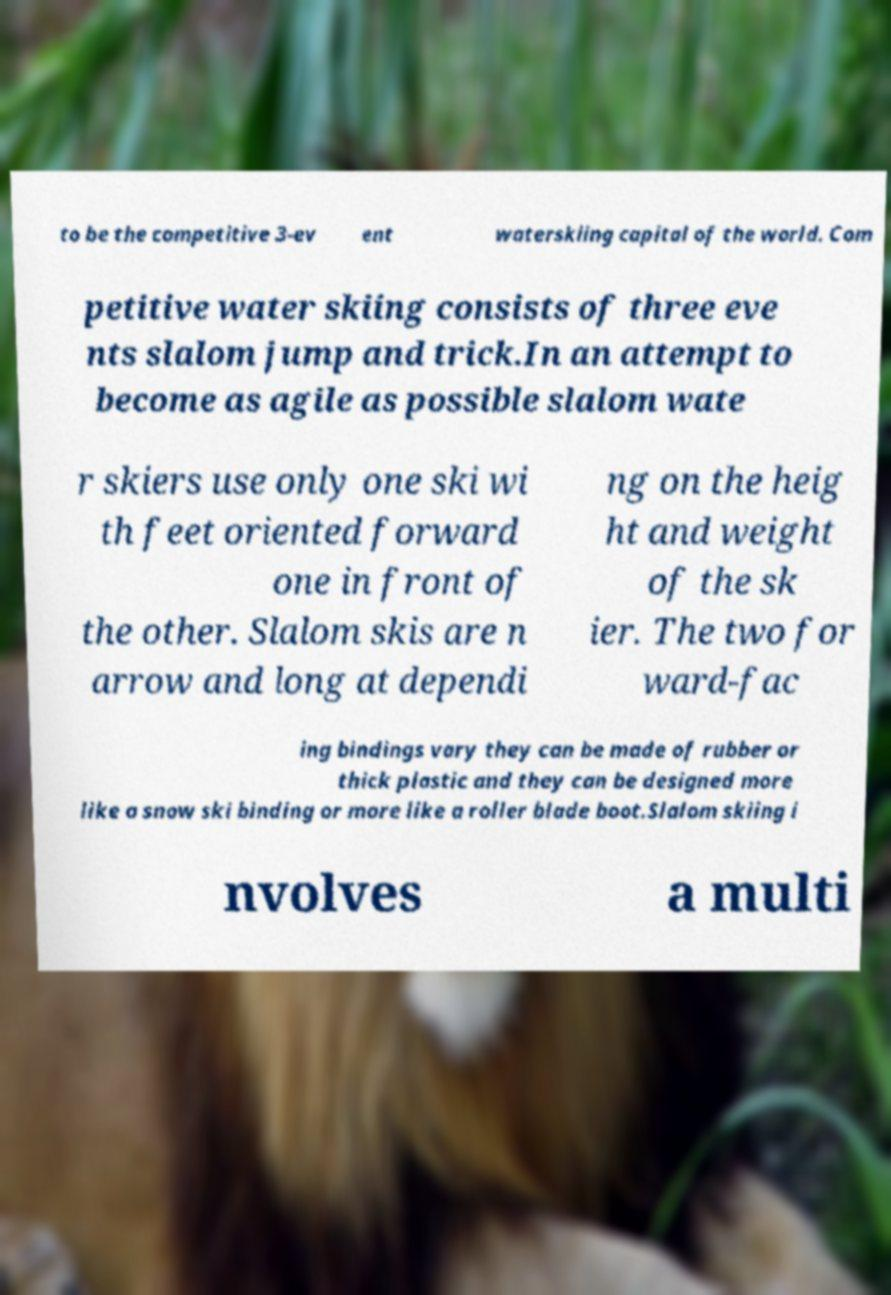Could you assist in decoding the text presented in this image and type it out clearly? to be the competitive 3-ev ent waterskiing capital of the world. Com petitive water skiing consists of three eve nts slalom jump and trick.In an attempt to become as agile as possible slalom wate r skiers use only one ski wi th feet oriented forward one in front of the other. Slalom skis are n arrow and long at dependi ng on the heig ht and weight of the sk ier. The two for ward-fac ing bindings vary they can be made of rubber or thick plastic and they can be designed more like a snow ski binding or more like a roller blade boot.Slalom skiing i nvolves a multi 